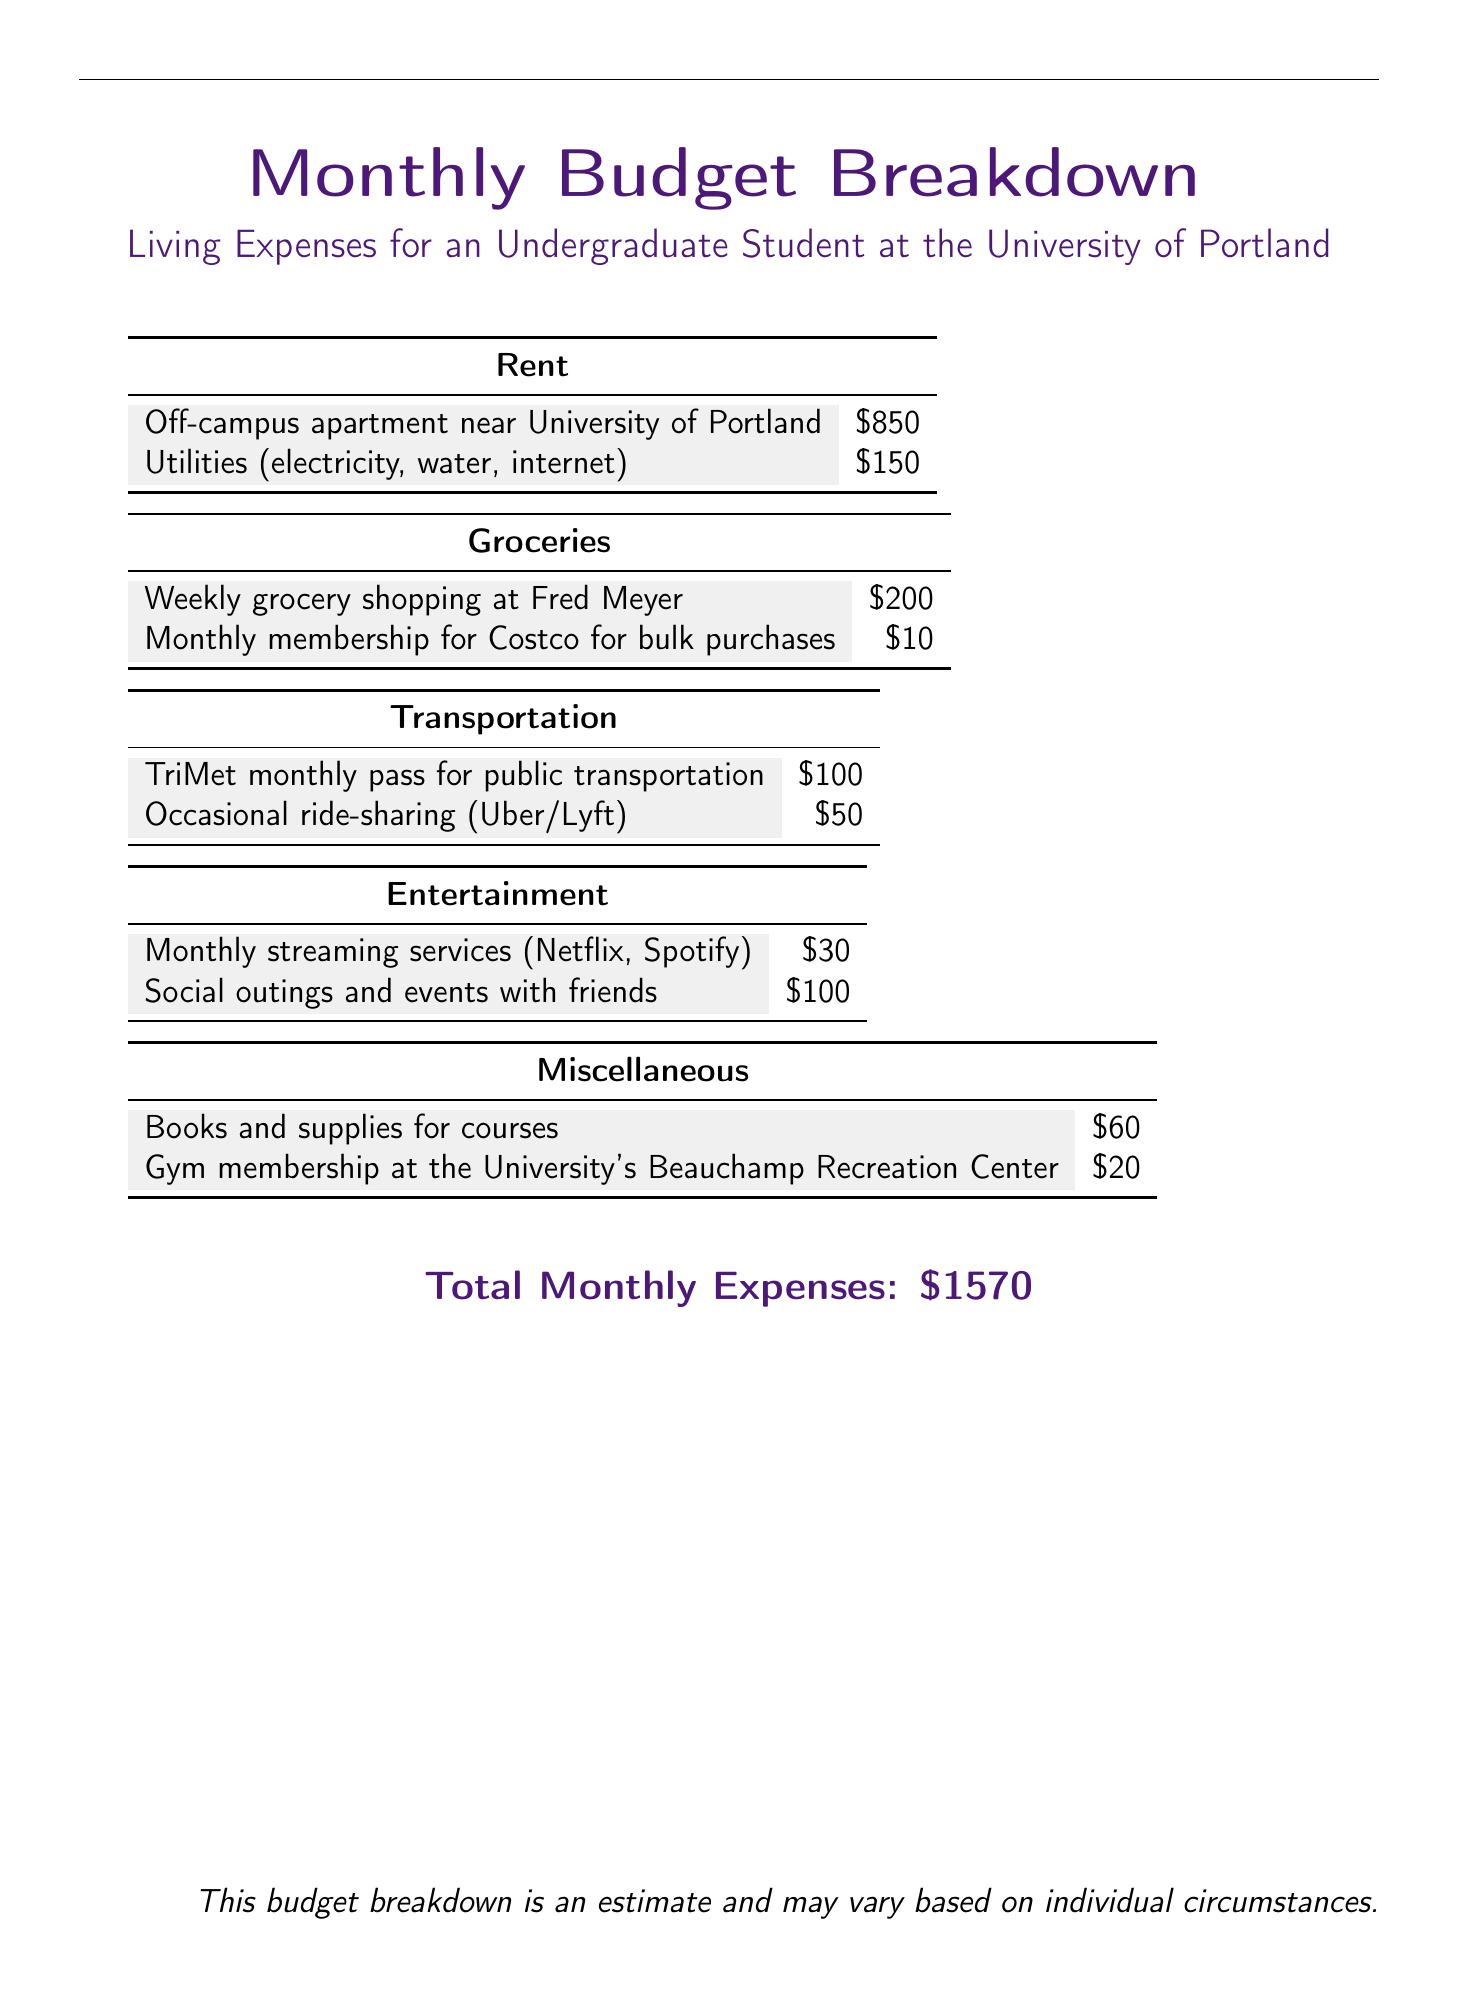What is the rent for the off-campus apartment? The document specifies that the rent for the off-campus apartment is $850.
Answer: $850 How much do utilities cost? The document states the cost of utilities as $150.
Answer: $150 What is the weekly grocery shopping amount? The document indicates that weekly grocery shopping at Fred Meyer costs $200.
Answer: $200 What is the total cost for groceries including the Costco membership? To find the total for groceries, add the weekly grocery cost of $200 to the monthly membership fee of $10, resulting in $210.
Answer: $210 What is the cost of the TriMet monthly pass? According to the document, the TriMet monthly pass costs $100.
Answer: $100 How much is budgeted for entertainment from social outings and events? The document lists the budget for social outings and events as $100.
Answer: $100 What is the total transportation cost? The transportation total is calculated by summing the TriMet monthly pass ($100) and occasional ride-sharing ($50), which equals $150.
Answer: $150 How much is spent on books and supplies for courses? The document states that books and supplies for courses cost $60.
Answer: $60 What is the total monthly expense? The total monthly expenses as outlined in the document sum to $1570.
Answer: $1570 